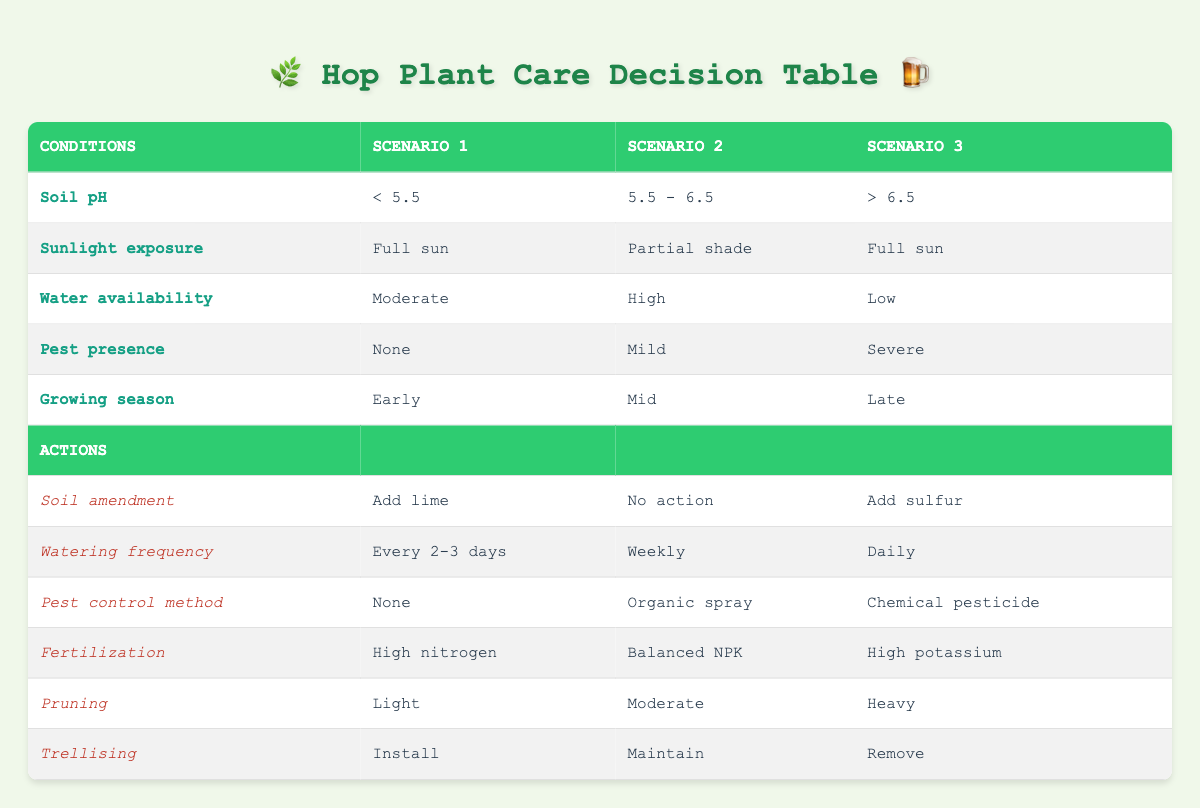What soil pH is associated with adding lime? According to the table, adding lime is indicated when the soil pH is less than 5.5. Therefore, the answer corresponds directly to the conditions outlined in the first scenario.
Answer: < 5.5 What is the watering frequency when the water availability is high? Referring to the second scenario in the table, when the water availability is high, the watering frequency is set to weekly as detailed in the actions corresponding to that condition.
Answer: Weekly Is organic spray recommended if pest presence is mild? Yes, the table states that when pest presence is mild, the pest control method recommended is organic spray. This is specified in the actions for the second scenario.
Answer: Yes Which fertilization method is suggested for conditions with a soil pH above 6.5? The table shows that for conditions where the soil pH is greater than 6.5, the recommended fertilization method is high potassium, as outlined in the actions tied to the third scenario.
Answer: High potassium In the early growing season with moderate water availability, how should you handle trellising? For an early growing season with moderate water availability (described in the first scenario), the action for trellising is to install it. This involves looking at the conditions specified in the rules of the table.
Answer: Install What is the difference in watering frequency between moderate and high water availability? Moderate water availability specifies a frequency of every 2-3 days (first scenario), while high water availability specifies weekly (second scenario). The difference is that every 2-3 days is more frequent than weekly, indicating less watering when water availability is high.
Answer: Every 2-3 days and Weekly Is there any scenario where no action is recommended for soil amendment? Yes, the second scenario indicates that when the soil pH is between 5.5 and 6.5, no action is recommended for soil amendment. This directly shows that under specific conditions, no amendments are necessary.
Answer: Yes How would pest control differ between scenarios with severe pest presence compared to none? In scenarios where there is severe pest presence, the control method is a chemical pesticide (third scenario), while no action is taken when pest presence is none (first scenario). Therefore, the difference lies in using a chemical method when pests are severe versus not using any control when there are none.
Answer: Chemical pesticide and None What actions are suggested for a plant that has high water availability and falls under mild pest presence during mid growing season? The second scenario outlines that if water availability is high and there is mild pest presence in the mid growing season, the actions are no action for soil amendment, watering weekly, pest control with organic spray, using balanced NPK for fertilization, moderate pruning, and maintaining trellising. This requires referencing multiple points of the table simultaneously.
Answer: Multiple actions: No action, Weekly, Organic spray, Balanced NPK, Moderate, Maintain 